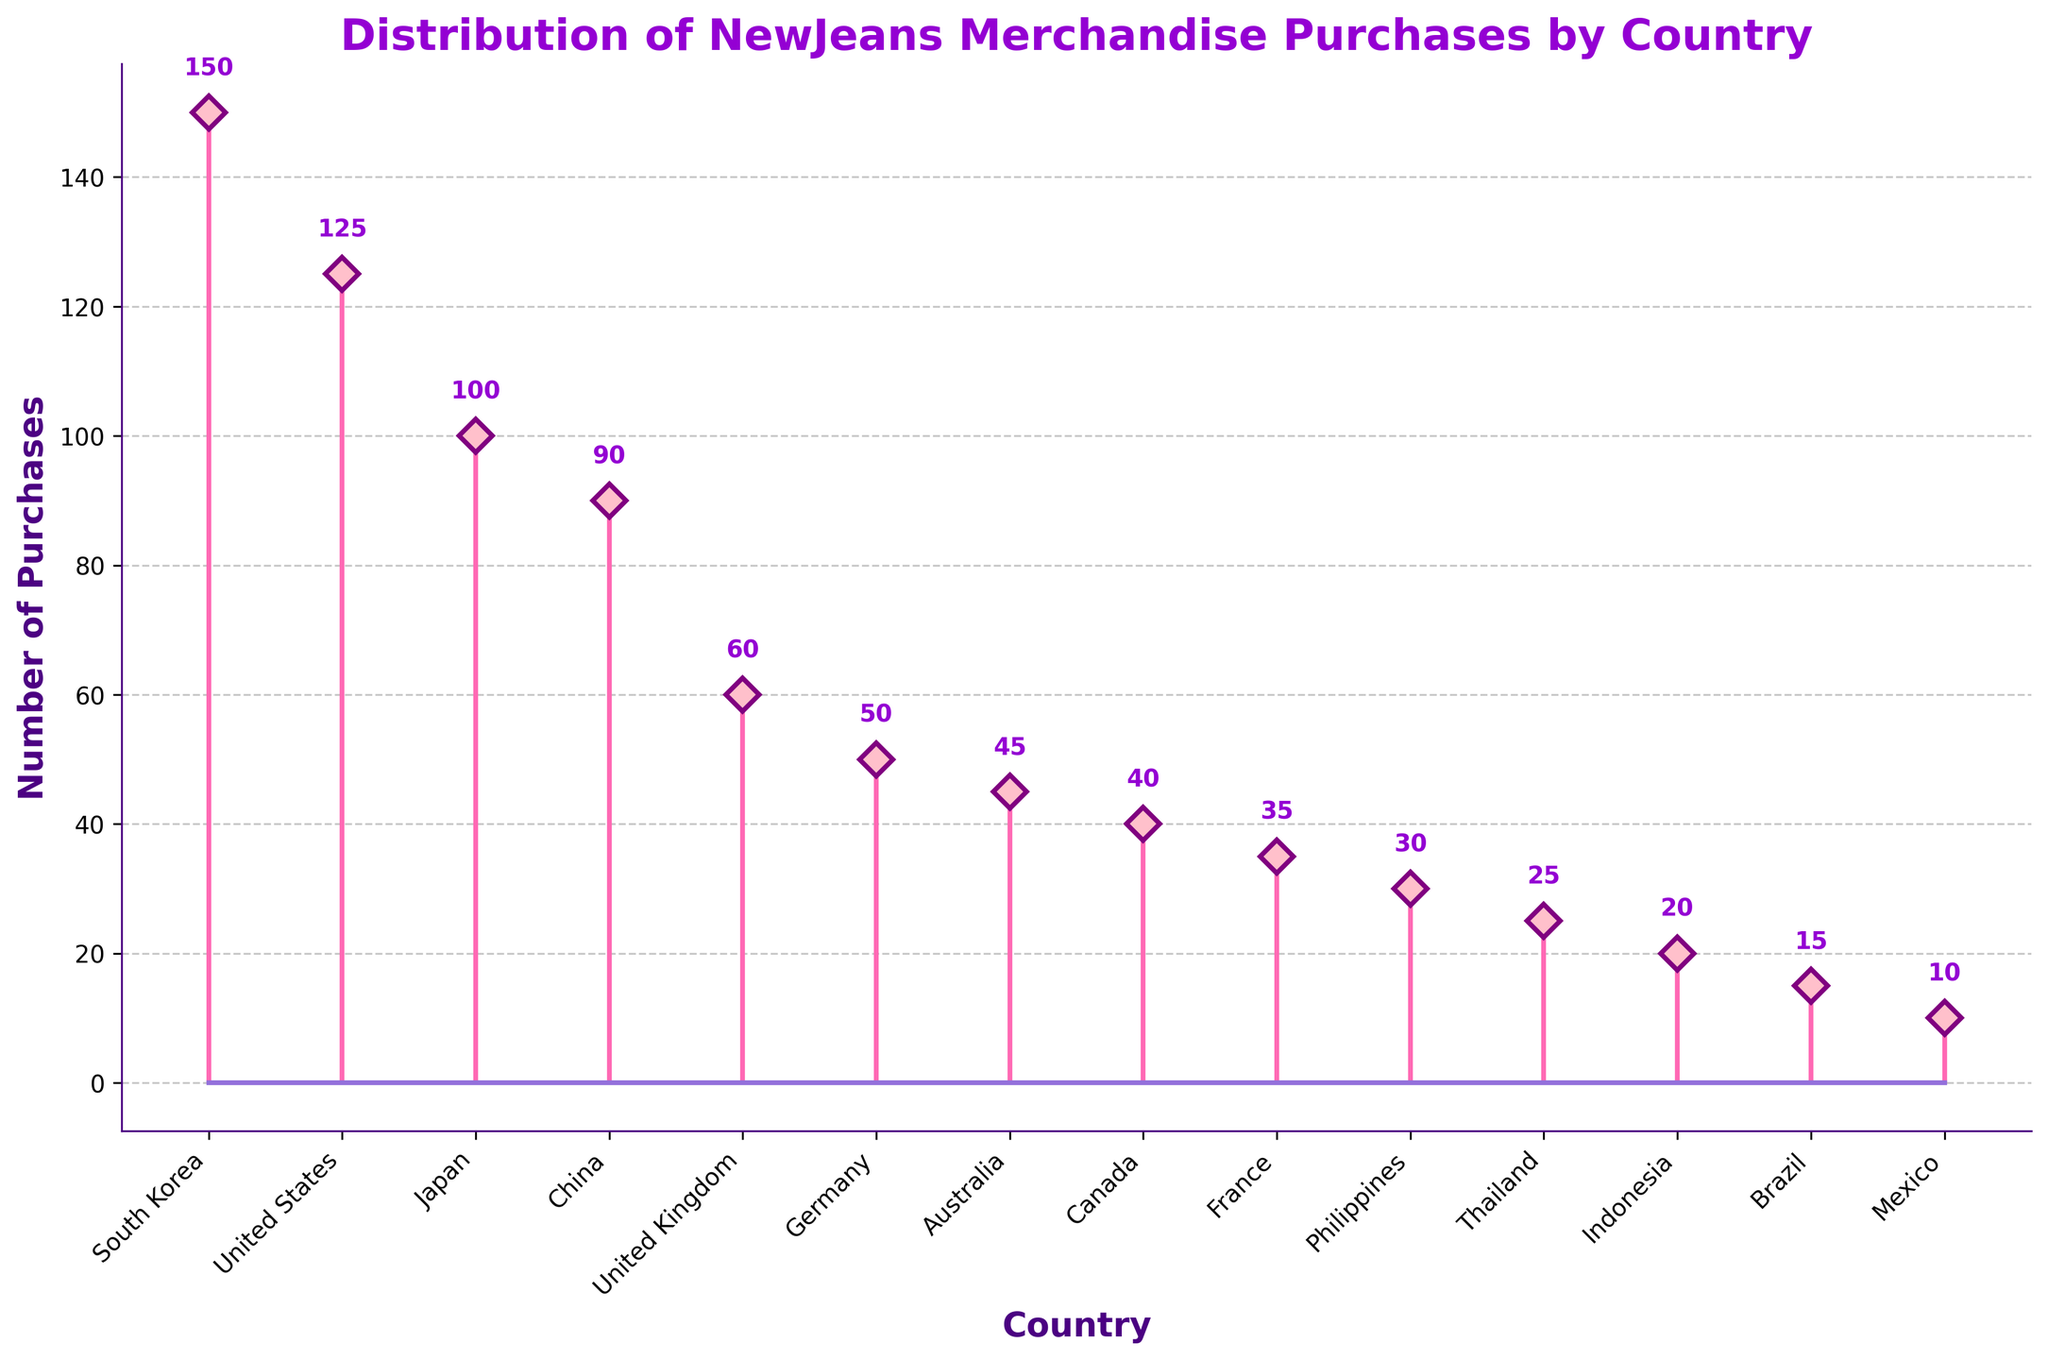What is the highest number of purchases for NewJeans merchandise by country? The highest stem in the plot represents the highest number of purchases, which is associated with South Korea at the value of 150.
Answer: 150 Which country made the least amount of NewJeans merchandise purchases? The smallest stem in the plot represents the least number of purchases, which is associated with Mexico at the value of 10.
Answer: Mexico How many countries have more than 50 purchases? By visually inspecting the stems, count the number of countries where the stem height exceeds 50. South Korea, United States, Japan, China, United Kingdom, and Germany meet this criterion, totaling 6 countries.
Answer: 6 What is the total number of purchases from United States and Japan combined? Locate the stems for the United States (125) and Japan (100) and add the values. 125 + 100 = 225.
Answer: 225 What is the approximate difference in the number of purchases between South Korea and China? Locate the stems for South Korea (150) and China (90). Subtract the smaller value from the larger value. 150 - 90 = 60.
Answer: 60 Which country has purchases closest to 35? Identify the country with a stem value closest to 35 by examining the plot. France has exactly 35 purchases.
Answer: France Is there a bigger gap in purchases between China and United Kingdom or between United Kingdom and Germany? First, calculate the differences: China (90) - United Kingdom (60) = 30. United Kingdom (60) - Germany (50) = 10. The gap between China and United Kingdom is bigger.
Answer: China and United Kingdom What is the average number of purchases for Australia, Canada, and France? Locate the stems for Australia (45), Canada (40), and France (35), and calculate their average: (45 + 40 + 35) / 3 = 40.
Answer: 40 How many purchases were made in Asian countries according to the plot? Identify the Asian countries: South Korea (150), Japan (100), China (90), Philippines (30), Thailand (25), and Indonesia (20). Sum the values: 150 + 100 + 90 + 30 + 25 + 20 = 415.
Answer: 415 Which country has more purchases, Germany or Canada? Compare the stem heights of Germany (50) and Canada (40). Germany has more purchases.
Answer: Germany 